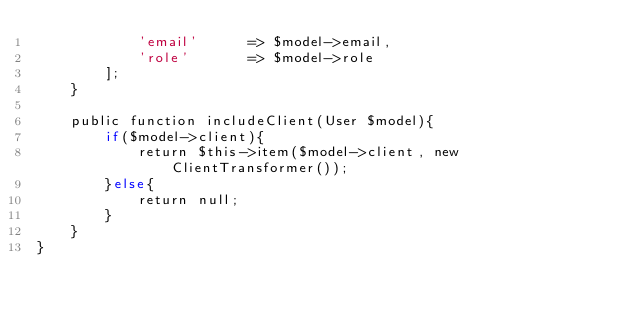<code> <loc_0><loc_0><loc_500><loc_500><_PHP_>            'email'      => $model->email,
            'role'       => $model->role
        ];
    }

    public function includeClient(User $model){
        if($model->client){
            return $this->item($model->client, new ClientTransformer());
        }else{
            return null;
        }
    }
}
</code> 